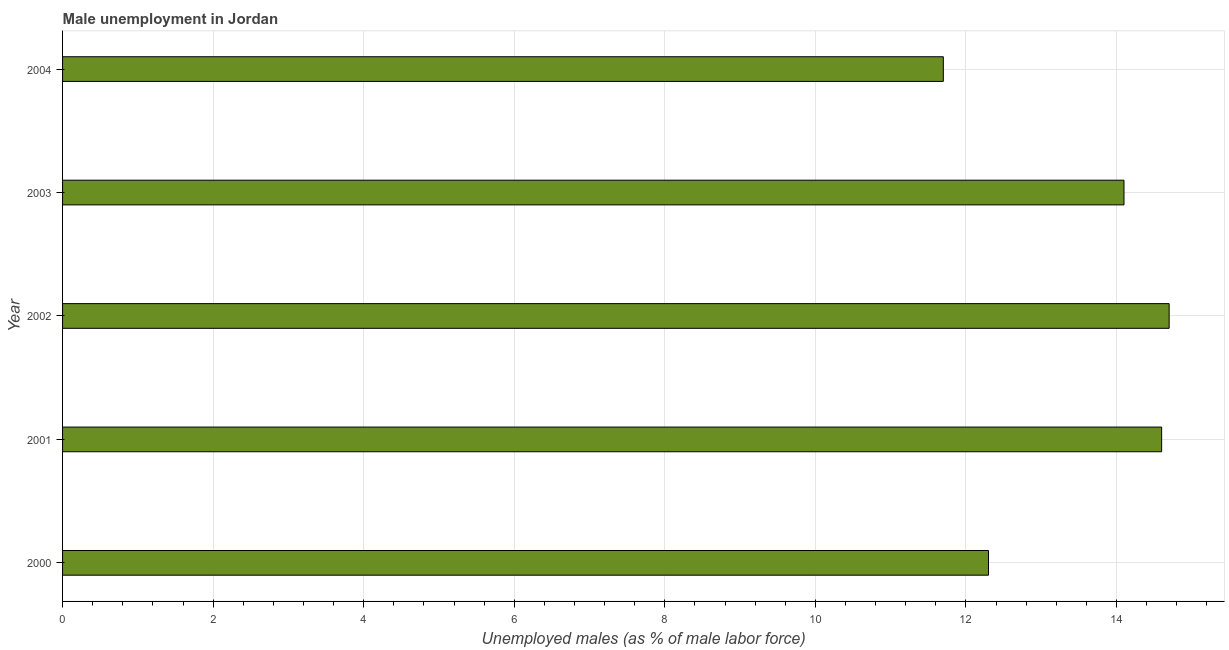What is the title of the graph?
Give a very brief answer. Male unemployment in Jordan. What is the label or title of the X-axis?
Make the answer very short. Unemployed males (as % of male labor force). What is the unemployed males population in 2000?
Offer a very short reply. 12.3. Across all years, what is the maximum unemployed males population?
Provide a short and direct response. 14.7. Across all years, what is the minimum unemployed males population?
Give a very brief answer. 11.7. In which year was the unemployed males population maximum?
Offer a terse response. 2002. What is the sum of the unemployed males population?
Ensure brevity in your answer.  67.4. What is the difference between the unemployed males population in 2000 and 2002?
Keep it short and to the point. -2.4. What is the average unemployed males population per year?
Your answer should be very brief. 13.48. What is the median unemployed males population?
Offer a very short reply. 14.1. In how many years, is the unemployed males population greater than 1.2 %?
Offer a very short reply. 5. Is the unemployed males population in 2002 less than that in 2003?
Your answer should be very brief. No. Is the difference between the unemployed males population in 2001 and 2003 greater than the difference between any two years?
Offer a very short reply. No. What is the difference between the highest and the second highest unemployed males population?
Ensure brevity in your answer.  0.1. Is the sum of the unemployed males population in 2002 and 2003 greater than the maximum unemployed males population across all years?
Provide a succinct answer. Yes. What is the difference between the highest and the lowest unemployed males population?
Your answer should be compact. 3. How many bars are there?
Give a very brief answer. 5. What is the Unemployed males (as % of male labor force) of 2000?
Your answer should be compact. 12.3. What is the Unemployed males (as % of male labor force) of 2001?
Provide a succinct answer. 14.6. What is the Unemployed males (as % of male labor force) of 2002?
Ensure brevity in your answer.  14.7. What is the Unemployed males (as % of male labor force) of 2003?
Ensure brevity in your answer.  14.1. What is the Unemployed males (as % of male labor force) of 2004?
Your answer should be compact. 11.7. What is the difference between the Unemployed males (as % of male labor force) in 2000 and 2003?
Offer a very short reply. -1.8. What is the difference between the Unemployed males (as % of male labor force) in 2001 and 2004?
Your answer should be very brief. 2.9. What is the difference between the Unemployed males (as % of male labor force) in 2002 and 2003?
Make the answer very short. 0.6. What is the difference between the Unemployed males (as % of male labor force) in 2002 and 2004?
Offer a very short reply. 3. What is the ratio of the Unemployed males (as % of male labor force) in 2000 to that in 2001?
Provide a succinct answer. 0.84. What is the ratio of the Unemployed males (as % of male labor force) in 2000 to that in 2002?
Ensure brevity in your answer.  0.84. What is the ratio of the Unemployed males (as % of male labor force) in 2000 to that in 2003?
Ensure brevity in your answer.  0.87. What is the ratio of the Unemployed males (as % of male labor force) in 2000 to that in 2004?
Your answer should be very brief. 1.05. What is the ratio of the Unemployed males (as % of male labor force) in 2001 to that in 2003?
Ensure brevity in your answer.  1.03. What is the ratio of the Unemployed males (as % of male labor force) in 2001 to that in 2004?
Ensure brevity in your answer.  1.25. What is the ratio of the Unemployed males (as % of male labor force) in 2002 to that in 2003?
Your answer should be very brief. 1.04. What is the ratio of the Unemployed males (as % of male labor force) in 2002 to that in 2004?
Offer a terse response. 1.26. What is the ratio of the Unemployed males (as % of male labor force) in 2003 to that in 2004?
Your response must be concise. 1.21. 